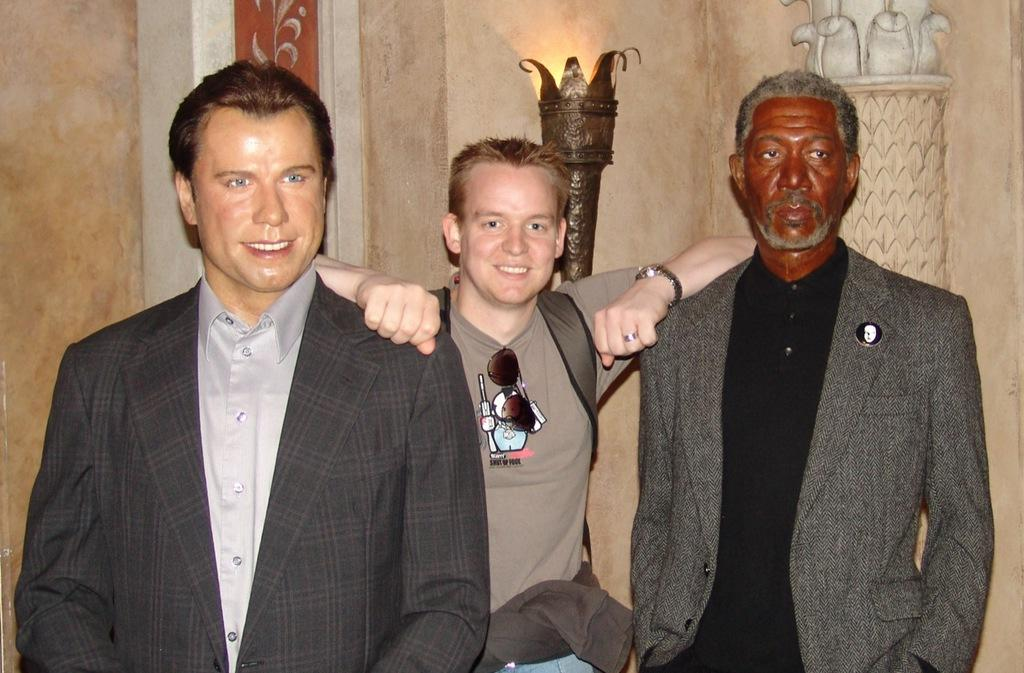What is the main subject of the image? The main subject of the image is a man. What is the man doing in the image? The man is standing between two sculptures. What can be observed about the man's attire? The man is wearing clothes, a finger ring, and a wrist watch. What is the man's facial expression in the image? The man is smiling. What other objects are present in the image? There is a wall and a lamp in the image. What type of bun is the man holding in the image? There is no bun present in the image; the man is standing between two sculptures and wearing a finger ring and a wrist watch. What color is the crayon the man is using to draw on the wall? There is no crayon or drawing on the wall in the image; the man is simply standing between two sculptures and smiling. 